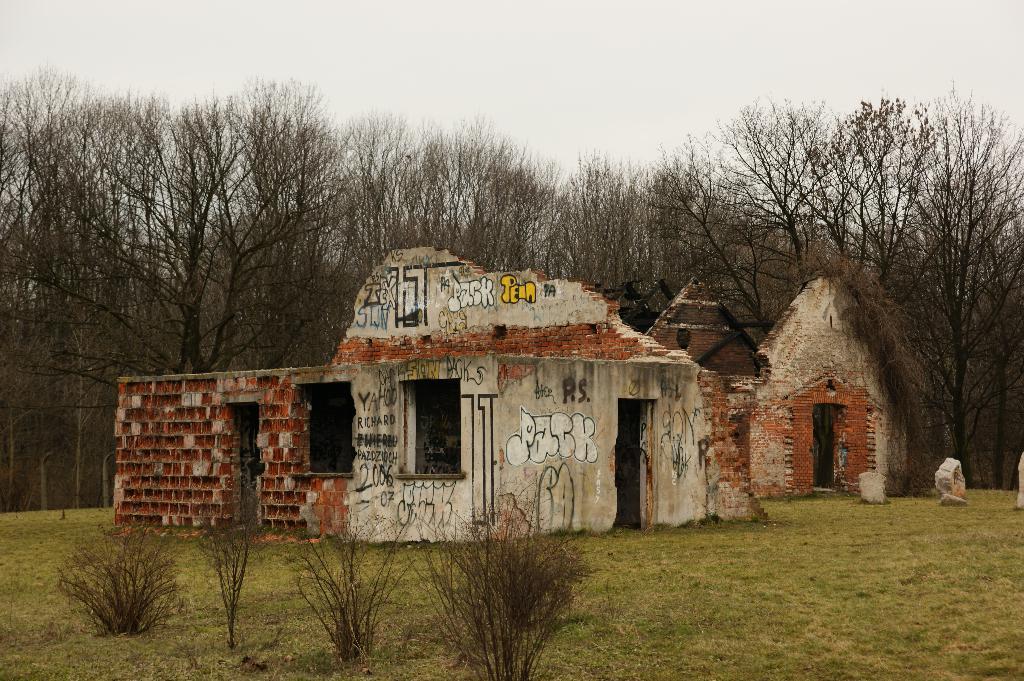Describe this image in one or two sentences. In front of the image there are plants. At the bottom of the image there is grass on the surface. There are buildings. There is painting on the building. In the background of the image there are trees and sky. 